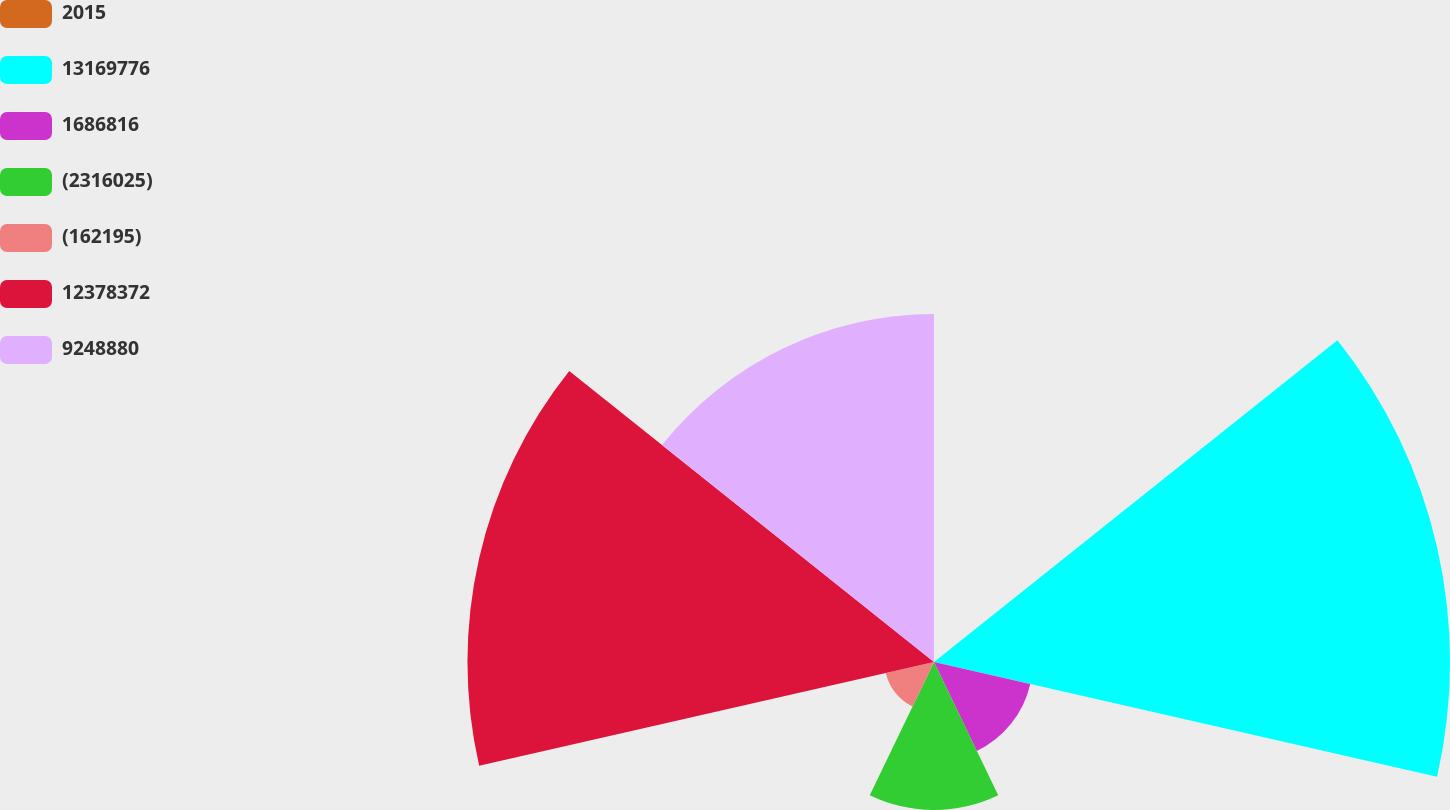<chart> <loc_0><loc_0><loc_500><loc_500><pie_chart><fcel>2015<fcel>13169776<fcel>1686816<fcel>(2316025)<fcel>(162195)<fcel>12378372<fcel>9248880<nl><fcel>0.0%<fcel>31.72%<fcel>6.07%<fcel>9.1%<fcel>3.04%<fcel>28.68%<fcel>21.39%<nl></chart> 